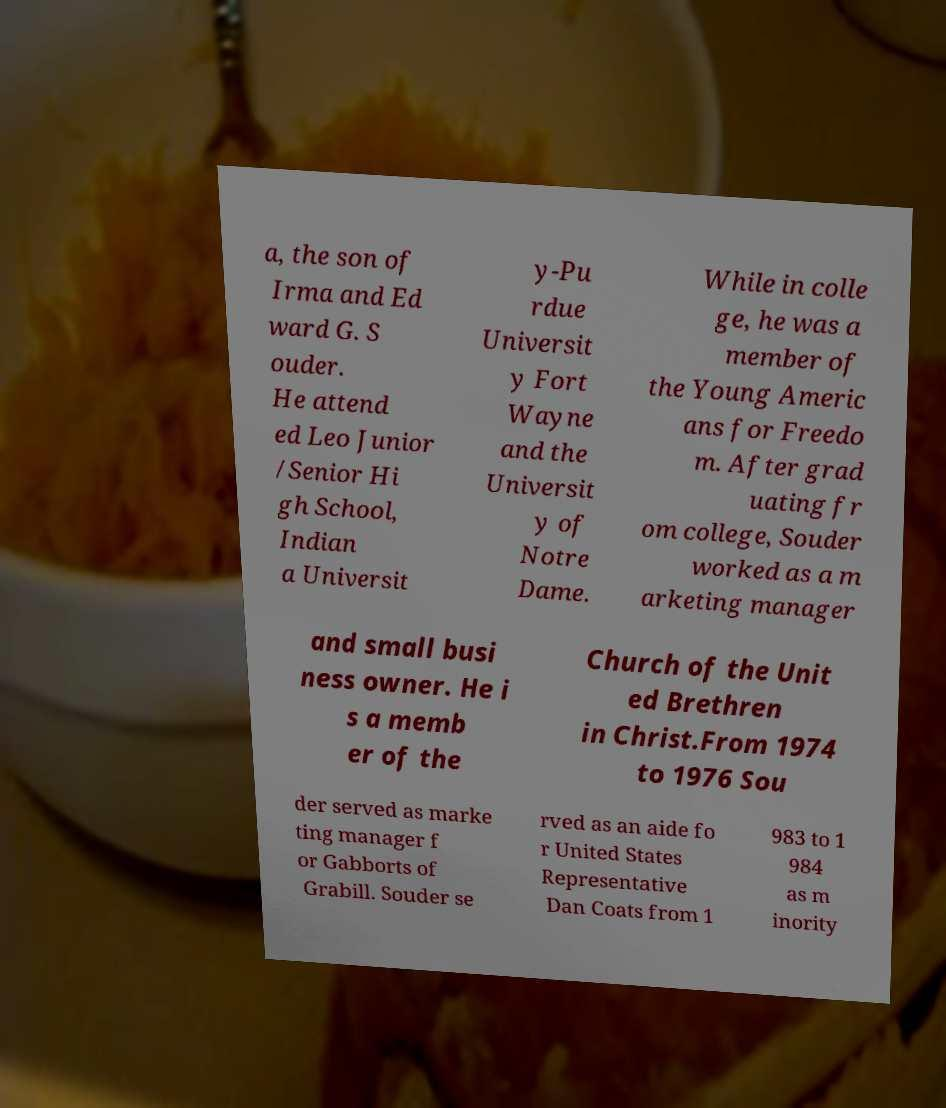Can you read and provide the text displayed in the image?This photo seems to have some interesting text. Can you extract and type it out for me? a, the son of Irma and Ed ward G. S ouder. He attend ed Leo Junior /Senior Hi gh School, Indian a Universit y-Pu rdue Universit y Fort Wayne and the Universit y of Notre Dame. While in colle ge, he was a member of the Young Americ ans for Freedo m. After grad uating fr om college, Souder worked as a m arketing manager and small busi ness owner. He i s a memb er of the Church of the Unit ed Brethren in Christ.From 1974 to 1976 Sou der served as marke ting manager f or Gabborts of Grabill. Souder se rved as an aide fo r United States Representative Dan Coats from 1 983 to 1 984 as m inority 